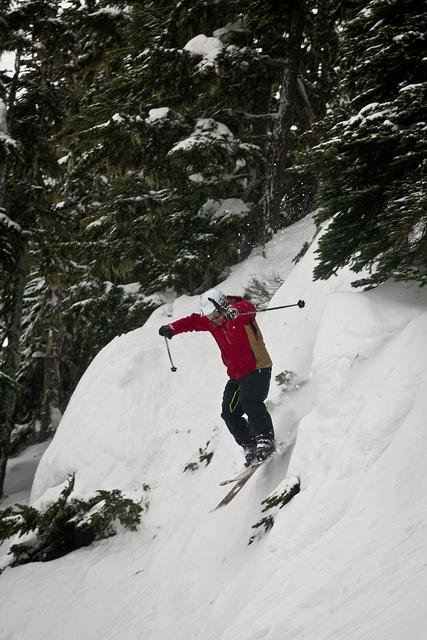What color coat is he wearing?
Give a very brief answer. Red. Is this person skiing?
Answer briefly. Yes. What is the person wearing on their feet?
Write a very short answer. Skis. How is the skier going to get out of this situation?
Be succinct. Jump. 